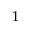<formula> <loc_0><loc_0><loc_500><loc_500>1</formula> 